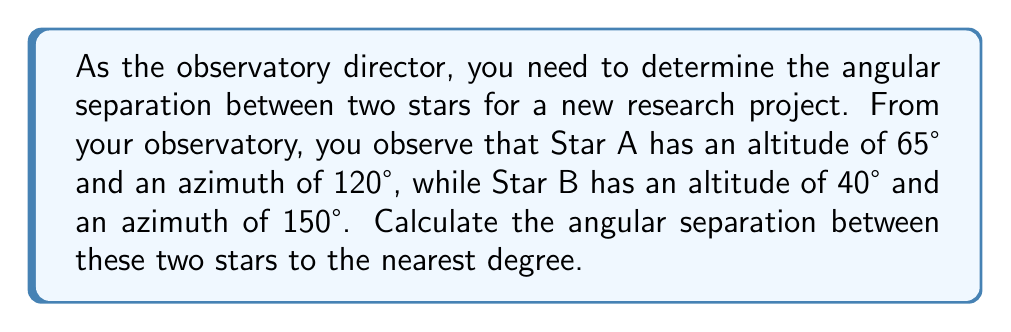Solve this math problem. To solve this problem, we'll use spherical trigonometry. The stars can be considered as points on a celestial sphere, and we need to find the great circle distance between them.

Step 1: Convert the given coordinates to 3D Cartesian coordinates.
For Star A: 
$$x_A = \cos(65°) \cdot \sin(120°)$$
$$y_A = \cos(65°) \cdot \cos(120°)$$
$$z_A = \sin(65°)$$

For Star B:
$$x_B = \cos(40°) \cdot \sin(150°)$$
$$y_B = \cos(40°) \cdot \cos(150°)$$
$$z_B = \sin(40°)$$

Step 2: Calculate the dot product of the two vectors.
$$\text{dot product} = x_A \cdot x_B + y_A \cdot y_B + z_A \cdot z_B$$

Step 3: Calculate the magnitudes of both vectors.
$$\text{magnitude}_A = \sqrt{x_A^2 + y_A^2 + z_A^2}$$
$$\text{magnitude}_B = \sqrt{x_B^2 + y_B^2 + z_B^2}$$

Step 4: Use the dot product formula to find the cosine of the angle between the vectors.
$$\cos(\theta) = \frac{\text{dot product}}{\text{magnitude}_A \cdot \text{magnitude}_B}$$

Step 5: Take the inverse cosine (arccos) to find the angle.
$$\theta = \arccos(\cos(\theta))$$

Step 6: Convert the result to degrees and round to the nearest degree.

Performing these calculations:

$$x_A \approx 0.1830, y_A \approx -0.3170, z_A \approx 0.9063$$
$$x_B \approx 0.6614, y_B \approx -0.3819, z_B \approx 0.6428$$

$$\text{dot product} \approx 0.8729$$
$$\text{magnitude}_A = \text{magnitude}_B = 1$$

$$\cos(\theta) \approx 0.8729$$
$$\theta \approx \arccos(0.8729) \approx 0.5055 \text{ radians}$$
$$\theta \approx 28.97° \approx 29°$$
Answer: 29° 